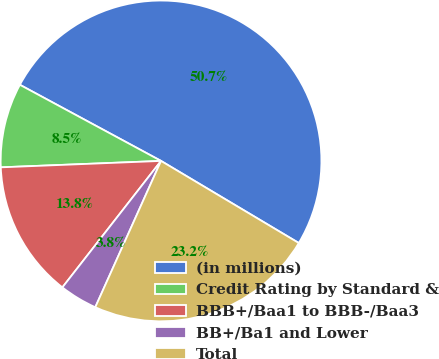Convert chart to OTSL. <chart><loc_0><loc_0><loc_500><loc_500><pie_chart><fcel>(in millions)<fcel>Credit Rating by Standard &<fcel>BBB+/Baa1 to BBB-/Baa3<fcel>BB+/Ba1 and Lower<fcel>Total<nl><fcel>50.68%<fcel>8.51%<fcel>13.82%<fcel>3.82%<fcel>23.17%<nl></chart> 